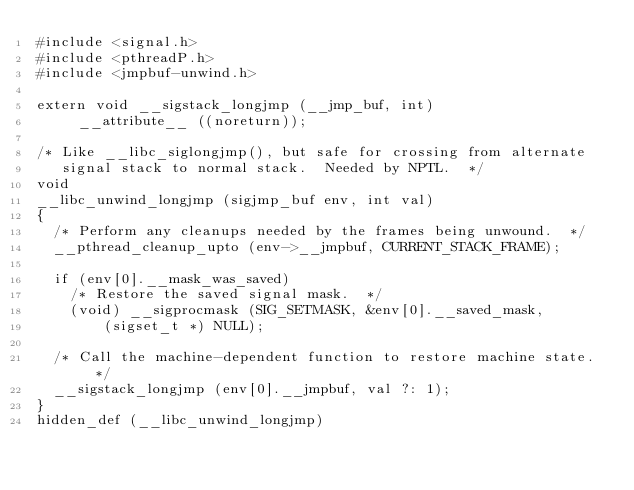Convert code to text. <code><loc_0><loc_0><loc_500><loc_500><_C_>#include <signal.h>
#include <pthreadP.h>
#include <jmpbuf-unwind.h>

extern void __sigstack_longjmp (__jmp_buf, int)
     __attribute__ ((noreturn));

/* Like __libc_siglongjmp(), but safe for crossing from alternate
   signal stack to normal stack.  Needed by NPTL.  */
void
__libc_unwind_longjmp (sigjmp_buf env, int val)
{
  /* Perform any cleanups needed by the frames being unwound.  */
  __pthread_cleanup_upto (env->__jmpbuf, CURRENT_STACK_FRAME);

  if (env[0].__mask_was_saved)
    /* Restore the saved signal mask.  */
    (void) __sigprocmask (SIG_SETMASK, &env[0].__saved_mask,
			  (sigset_t *) NULL);

  /* Call the machine-dependent function to restore machine state.  */
  __sigstack_longjmp (env[0].__jmpbuf, val ?: 1);
}
hidden_def (__libc_unwind_longjmp)
</code> 